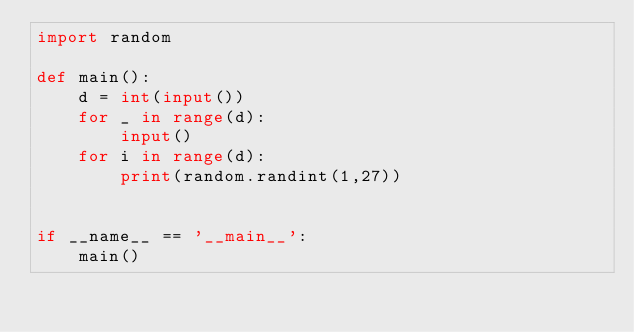Convert code to text. <code><loc_0><loc_0><loc_500><loc_500><_Python_>import random

def main():
    d = int(input())
    for _ in range(d):
        input()
    for i in range(d):
        print(random.randint(1,27))


if __name__ == '__main__':
    main()</code> 